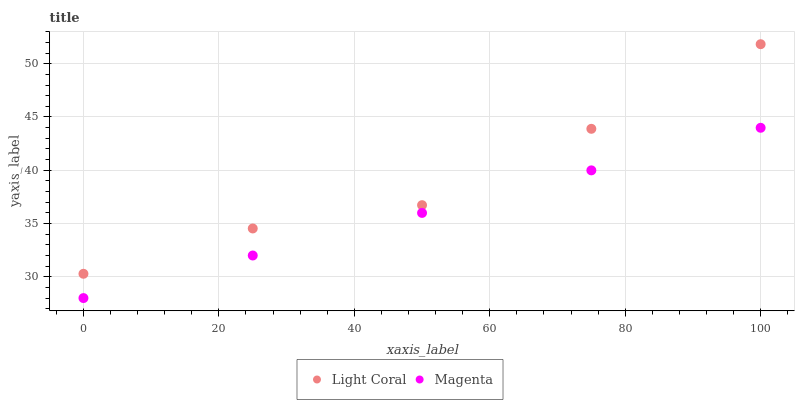Does Magenta have the minimum area under the curve?
Answer yes or no. Yes. Does Light Coral have the maximum area under the curve?
Answer yes or no. Yes. Does Magenta have the maximum area under the curve?
Answer yes or no. No. Is Magenta the smoothest?
Answer yes or no. Yes. Is Light Coral the roughest?
Answer yes or no. Yes. Is Magenta the roughest?
Answer yes or no. No. Does Magenta have the lowest value?
Answer yes or no. Yes. Does Light Coral have the highest value?
Answer yes or no. Yes. Does Magenta have the highest value?
Answer yes or no. No. Is Magenta less than Light Coral?
Answer yes or no. Yes. Is Light Coral greater than Magenta?
Answer yes or no. Yes. Does Magenta intersect Light Coral?
Answer yes or no. No. 